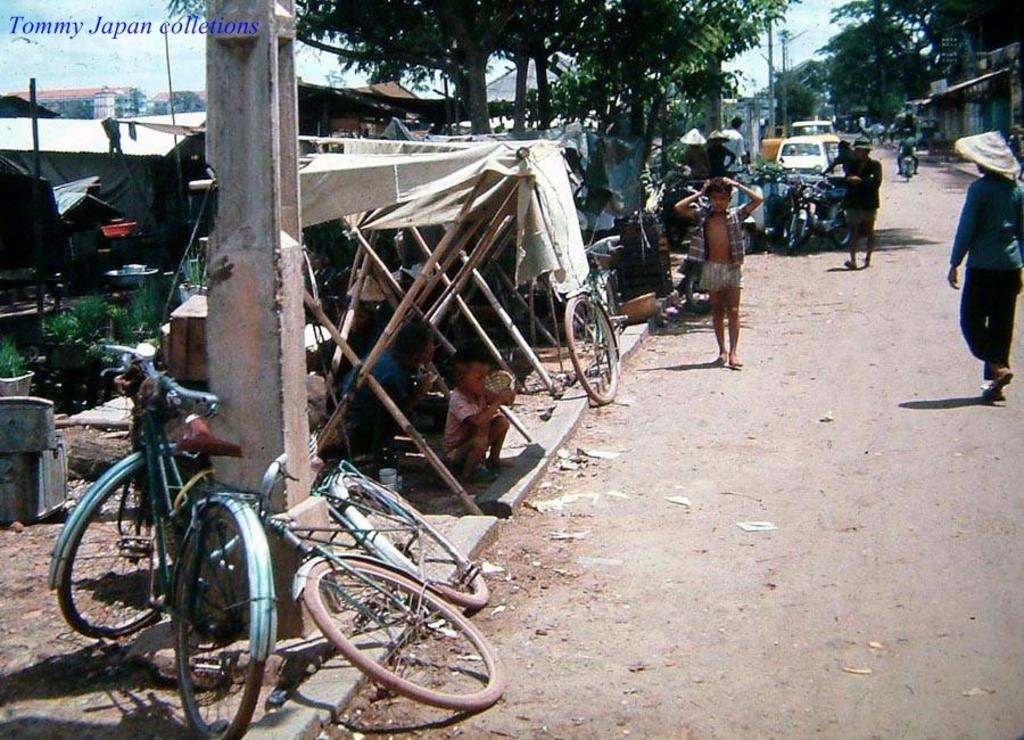Could you give a brief overview of what you see in this image? In the center of the image we can see people and there are vehicles on the road. On the left there are bicycles and there are tents. We can see trees. In the background there are buildings and sky. 